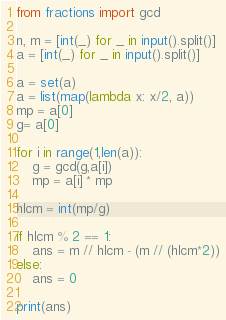<code> <loc_0><loc_0><loc_500><loc_500><_Python_>from fractions import gcd

n, m = [int(_) for _ in input().split()]
a = [int(_) for _ in input().split()]

a = set(a)
a = list(map(lambda x: x/2, a))
mp = a[0]
g= a[0]

for i in range(1,len(a)):
    g = gcd(g,a[i])
    mp = a[i] * mp

hlcm = int(mp/g)

if hlcm % 2 == 1:
    ans = m // hlcm - (m // (hlcm*2))
else:
    ans = 0

print(ans)</code> 